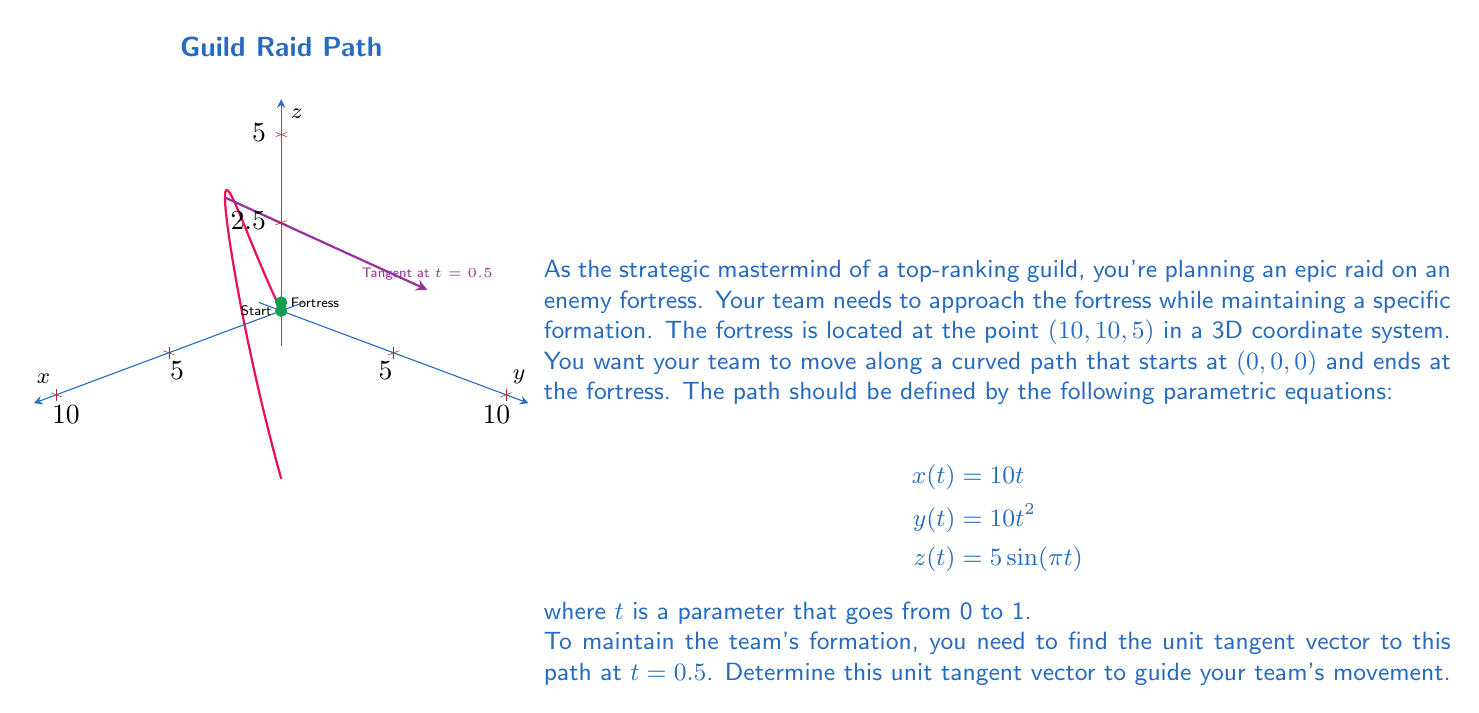Solve this math problem. To find the unit tangent vector at $t = 0.5$, we need to follow these steps:

1) First, we need to find the velocity vector $\mathbf{r}'(t)$ by differentiating each component of the position vector with respect to $t$:

   $$\mathbf{r}'(t) = \left(\frac{dx}{dt}, \frac{dy}{dt}, \frac{dz}{dt}\right)$$
   $$= (10, 20t, 5\pi\cos(\pi t))$$

2) Now, we evaluate this at $t = 0.5$:

   $$\mathbf{r}'(0.5) = (10, 20(0.5), 5\pi\cos(\pi(0.5)))$$
   $$= (10, 10, 0)$$

3) To get the unit tangent vector, we need to normalize this vector by dividing it by its magnitude. The magnitude is:

   $$\|\mathbf{r}'(0.5)\| = \sqrt{10^2 + 10^2 + 0^2} = \sqrt{200} = 10\sqrt{2}$$

4) Therefore, the unit tangent vector $\mathbf{T}(0.5)$ is:

   $$\mathbf{T}(0.5) = \frac{\mathbf{r}'(0.5)}{\|\mathbf{r}'(0.5)\|} = \frac{(10, 10, 0)}{10\sqrt{2}} = \left(\frac{1}{\sqrt{2}}, \frac{1}{\sqrt{2}}, 0\right)$$

This unit vector gives the direction in which the team should be moving at $t = 0.5$ to maintain their formation along the optimal path.
Answer: $\left(\frac{1}{\sqrt{2}}, \frac{1}{\sqrt{2}}, 0\right)$ 